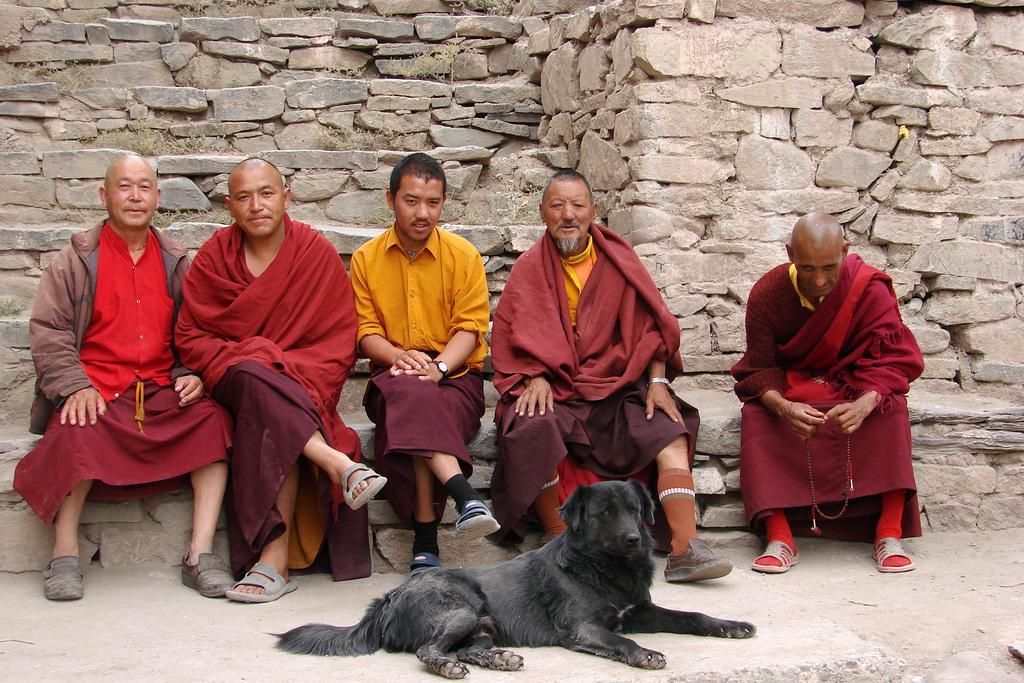Please provide a concise description of this image. This picture describes about group of people, they are all seated, in front of them we can see a dog, in the background we can see few rocks. 